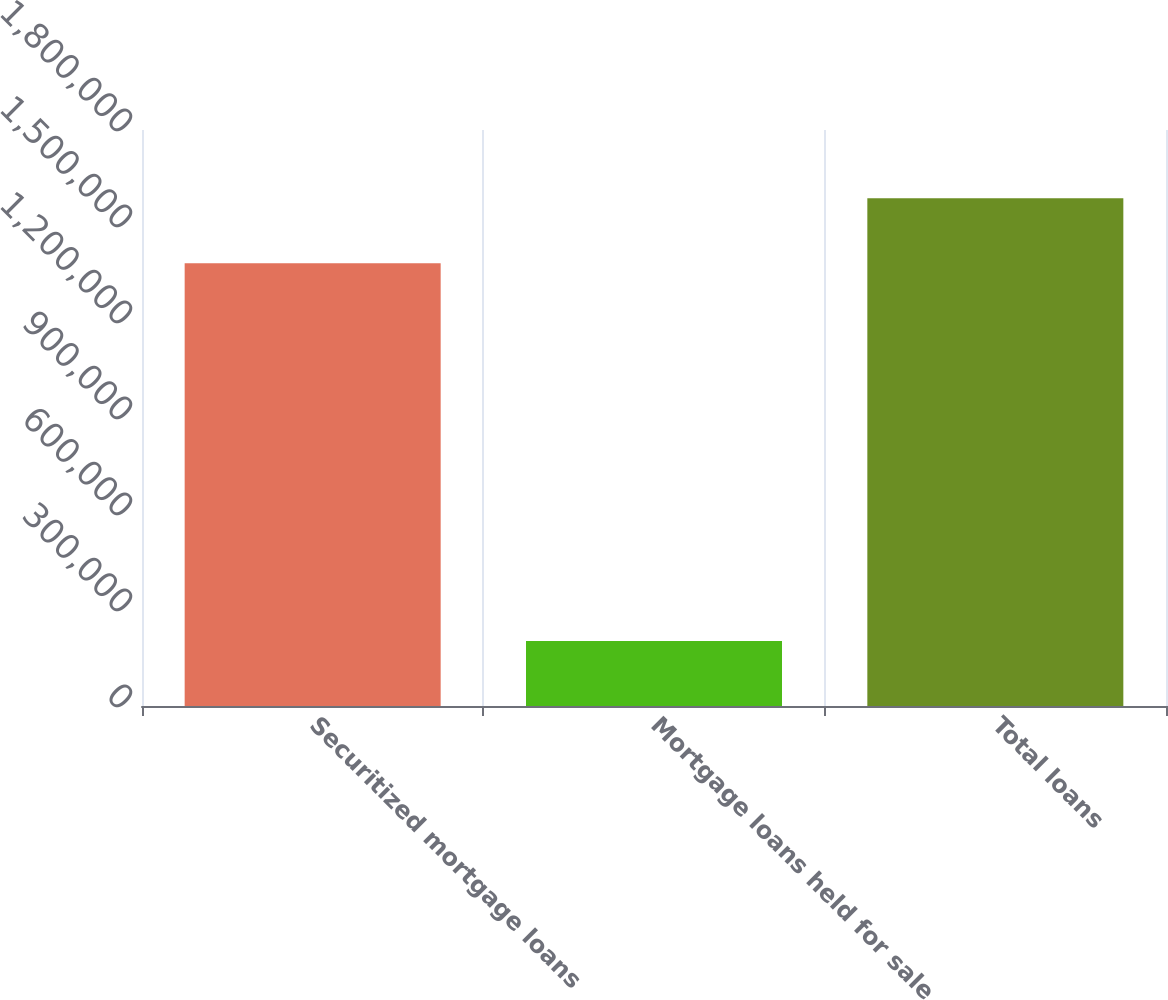Convert chart to OTSL. <chart><loc_0><loc_0><loc_500><loc_500><bar_chart><fcel>Securitized mortgage loans<fcel>Mortgage loans held for sale<fcel>Total loans<nl><fcel>1.38383e+06<fcel>202941<fcel>1.58677e+06<nl></chart> 